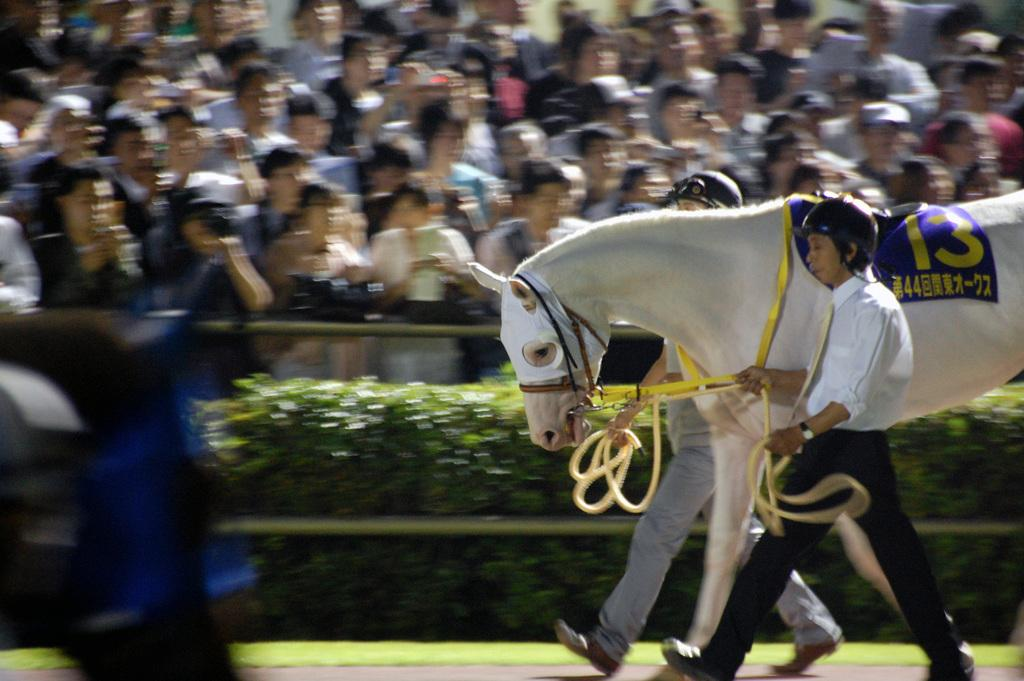What is the main subject of the image? The main subject of the image is a group of people. Are there any animals present in the image? Yes, there is a horse in the image. What is the relationship between the person and the horse in the image? A person is walking in front of the horse in the image. What type of advertisement can be seen on the horse in the image? There is no advertisement present on the horse in the image. How many oranges are being dropped by the horse in the image? There are no oranges present in the image, and the horse is not dropping anything. 